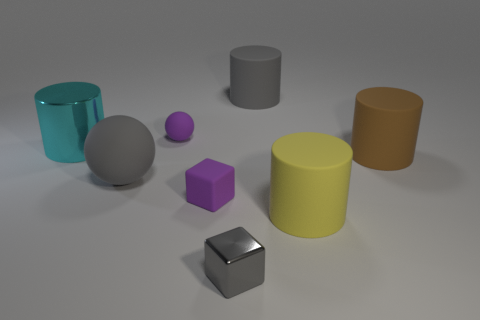Subtract all large yellow rubber cylinders. How many cylinders are left? 3 Add 2 yellow rubber cylinders. How many objects exist? 10 Subtract all gray cubes. How many cubes are left? 1 Subtract 3 cylinders. How many cylinders are left? 1 Subtract 0 green blocks. How many objects are left? 8 Subtract all balls. How many objects are left? 6 Subtract all purple cylinders. Subtract all blue spheres. How many cylinders are left? 4 Subtract all gray metal objects. Subtract all small things. How many objects are left? 4 Add 1 tiny cubes. How many tiny cubes are left? 3 Add 6 yellow objects. How many yellow objects exist? 7 